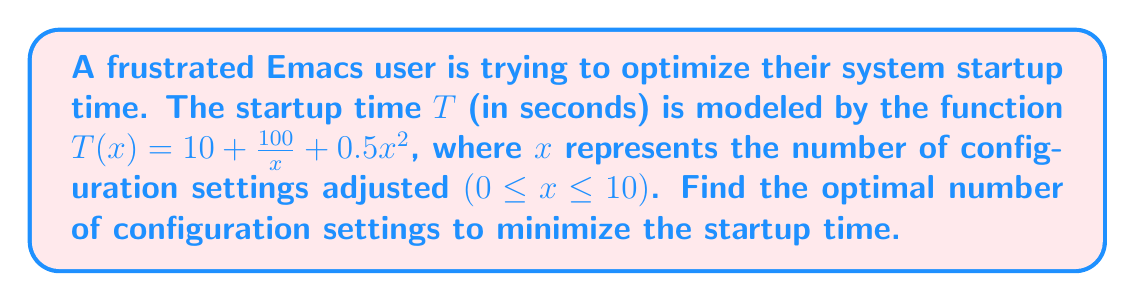Give your solution to this math problem. To find the optimal number of configuration settings, we need to minimize the function $T(x)$. This can be done by finding where the derivative of $T(x)$ equals zero.

Step 1: Calculate the derivative of $T(x)$
$$T'(x) = -\frac{100}{x^2} + x$$

Step 2: Set the derivative equal to zero and solve for x
$$-\frac{100}{x^2} + x = 0$$
$$x^3 = 100$$
$$x = \sqrt[3]{100} \approx 4.64$$

Step 3: Verify this is a minimum by checking the second derivative
$$T''(x) = \frac{200}{x^3} + 1$$
At $x = \sqrt[3]{100}$, $T''(x) > 0$, confirming a minimum.

Step 4: Since $x$ represents the number of configuration settings, we need to round to the nearest integer.
Rounding 4.64 to the nearest integer gives us 5.

Therefore, the optimal number of configuration settings to minimize startup time is 5.
Answer: 5 configuration settings 